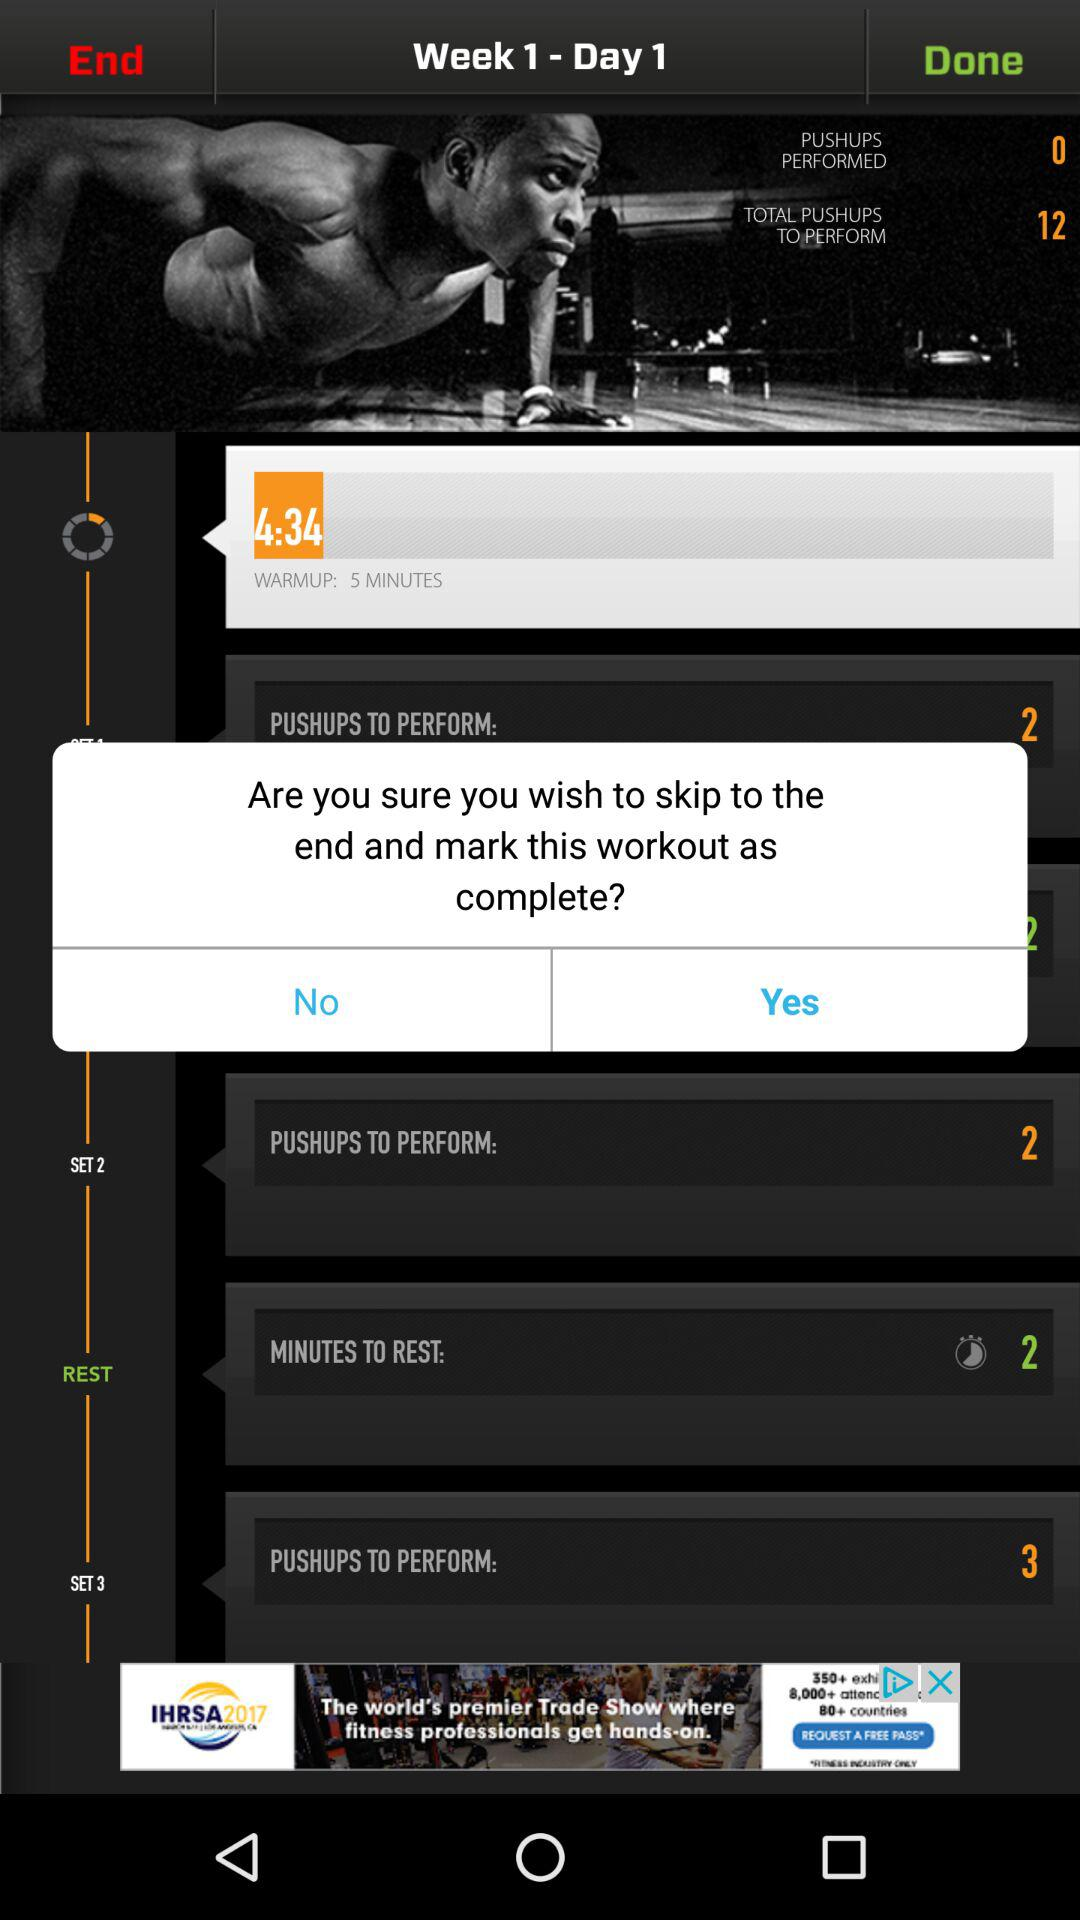How many push-ups are to be performed in Set 2? The number of push-ups to be performed in Set 2 is 2. 